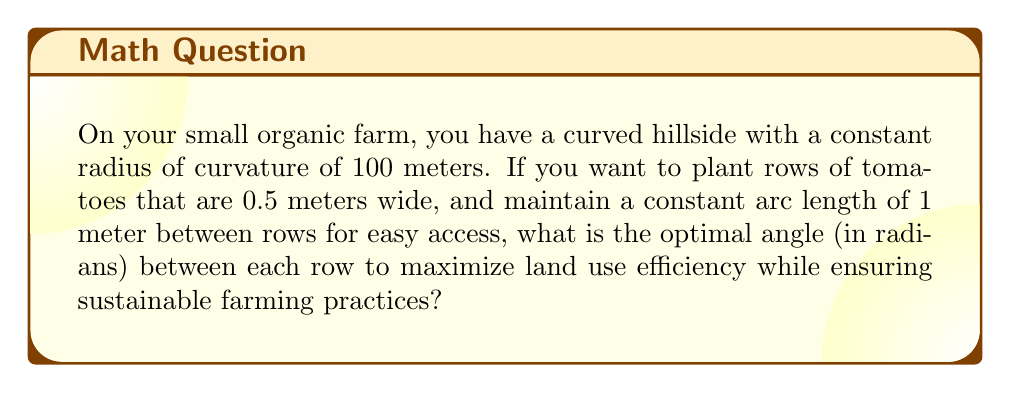Help me with this question. Let's approach this step-by-step using principles of non-Euclidean geometry:

1) In a curved space, the relationship between arc length $s$, radius $r$, and central angle $\theta$ (in radians) is given by:

   $$s = r\theta$$

2) We're given:
   - Radius of curvature, $r = 100$ meters
   - Desired arc length between rows, $s = 1$ meter

3) Substituting these into the formula:

   $$1 = 100\theta$$

4) Solving for $\theta$:

   $$\theta = \frac{1}{100} = 0.01 \text{ radians}$$

5) This angle represents the optimal spacing between the centers of each row. However, we need to account for the width of the tomato rows (0.5 meters).

6) The angle subtended by the width of a row can be calculated similarly:

   $$0.5 = 100\theta_{\text{row}}$$
   $$\theta_{\text{row}} = \frac{0.5}{100} = 0.005 \text{ radians}$$

7) The total angle between the start of one row and the start of the next should be:

   $$\theta_{\text{total}} = \theta + \theta_{\text{row}} = 0.01 + 0.005 = 0.015 \text{ radians}$$

This spacing maximizes land use efficiency while maintaining sustainable access paths between rows, suitable for a small-scale organic farm.
Answer: $0.015 \text{ radians}$ 